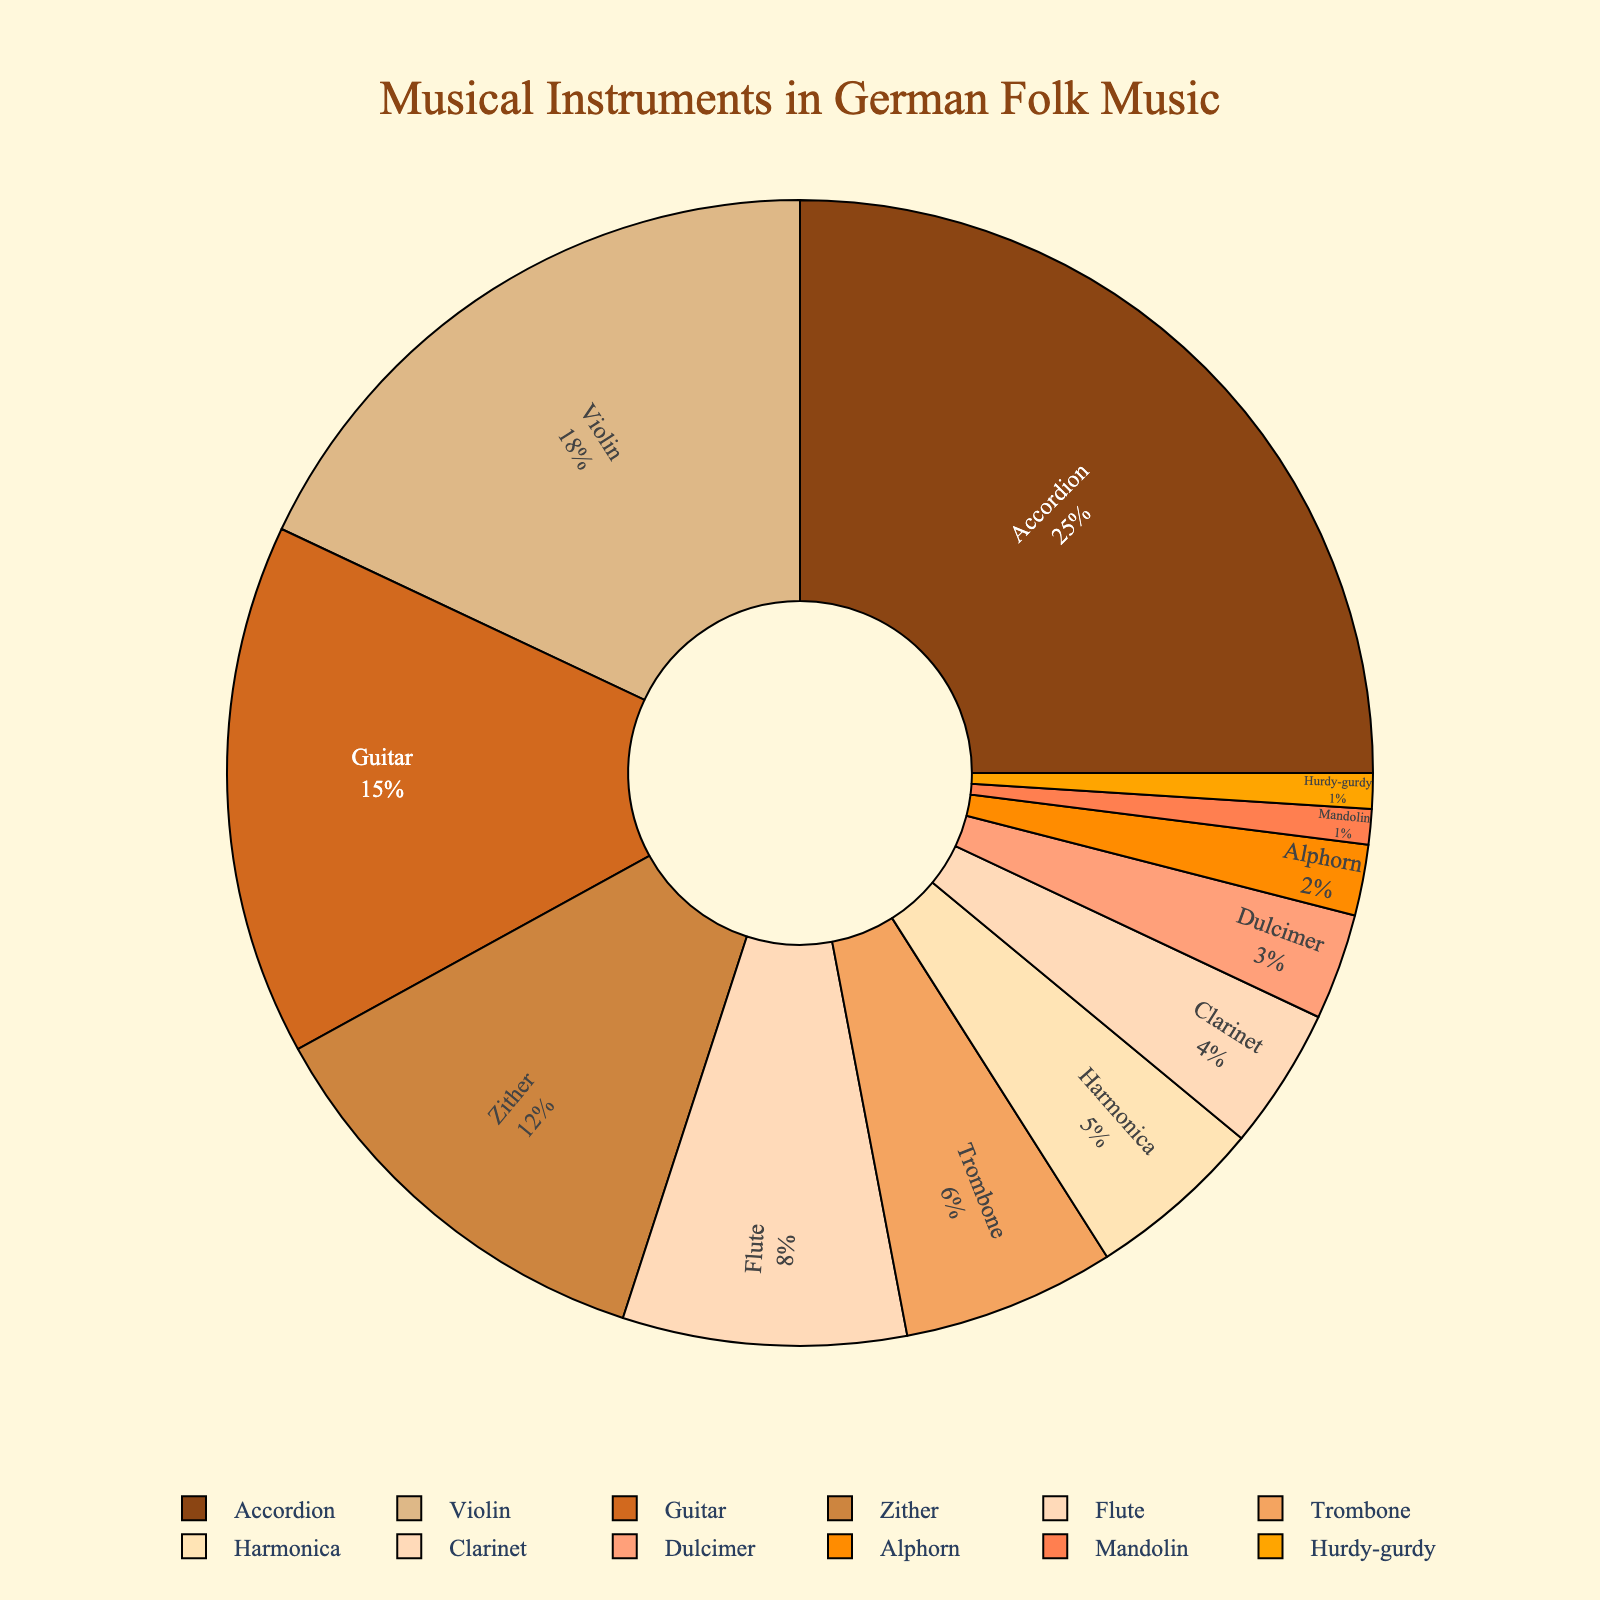What is the combined percentage of Accordion, Violin, and Guitar? To find the combined percentage of Accordion, Violin, and Guitar, sum their individual percentages: 25% (Accordion) + 18% (Violin) + 15% (Guitar) gives a total of 25 + 18 + 15 = 58%
Answer: 58% Which instrument has the smallest proportion? From the pie chart, the instrument with the smallest proportion is the one labeled with the smallest percentage. The Hurdy-gurdy and Mandolin both share the smallest proportion, each with 1%.
Answer: Hurdy-gurdy and Mandolin How does the proportion of the Violin compare to that of the Trombone? Compare the given percentages for Violin and Trombone: Violin is 18%, and Trombone is 6%. Therefore, Violin has a higher percentage compared to Trombone.
Answer: Violin has a higher percentage What percentage do all wind instruments (Flute, Trombone, Harmonica, Clarinet, and Alphorn) together constitute? To find the combined percentage of wind instruments, sum the percentages of Flute (8%), Trombone (6%), Harmonica (5%), Clarinet (4%), and Alphorn (2%): 8 + 6 + 5 + 4 + 2 = 25%.
Answer: 25% Which instrument's proportion is visually represented by the darkest color in the pie chart? By referring to the legend and visual shading, the instrument represented by the darkest color in the pie chart is Accordion, which has the highest proportion at 25%.
Answer: Accordion If the total number of instruments used is 100 and the proportion remains the same, how many instruments are Violins? Given that the percentage of Violin is 18%, to find the number of Violins in a total of 100 instruments, calculate 18% of 100, which is 18.
Answer: 18 Which three instruments have a combined percentage that is less than that of Accordion alone? Examine the percentages and find three instruments whose sum is less than 25%: Hurdy-gurdy (1%), Mandolin (1%), and Alphorn (2%) together make 1 + 1 + 2 = 4%, which is less than 25%.
Answer: Hurdy-gurdy, Mandolin, and Alphorn What is the difference in percentage between the Guitar and the Zither? Subtract the Zither's percentage from the Guitar's percentage: 15% (Guitar) - 12% (Zither) = 3%.
Answer: 3% Which instruments have a proportion smaller than the 5% threshold? Scan the chart for instruments with a proportion below 5%: Clarinet (4%), Dulcimer (3%), Alphorn (2%), Mandolin (1%), and Hurdy-gurdy (1%).
Answer: Clarinet, Dulcimer, Alphorn, Mandolin, and Hurdy-gurdy 